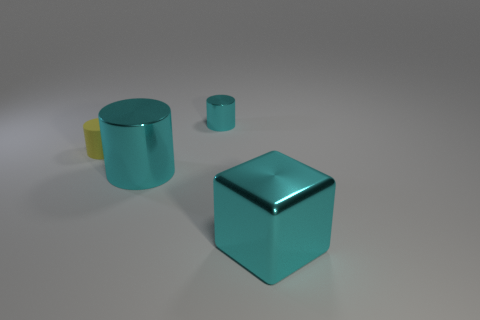Add 1 small yellow cylinders. How many objects exist? 5 Subtract all cylinders. How many objects are left? 1 Subtract all small red matte things. Subtract all rubber cylinders. How many objects are left? 3 Add 1 small objects. How many small objects are left? 3 Add 3 big metallic blocks. How many big metallic blocks exist? 4 Subtract 0 gray spheres. How many objects are left? 4 